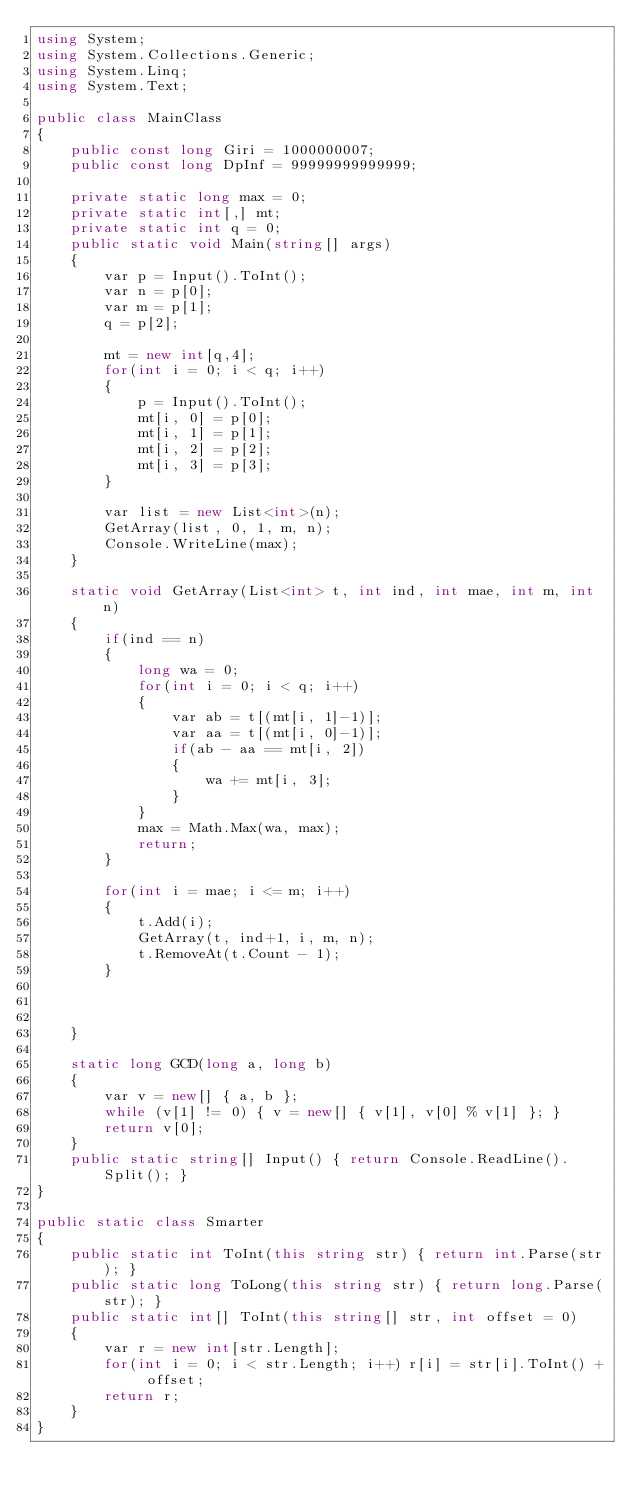<code> <loc_0><loc_0><loc_500><loc_500><_C#_>using System;
using System.Collections.Generic;
using System.Linq;
using System.Text;

public class MainClass
{
	public const long Giri = 1000000007;
	public const long DpInf = 99999999999999;
	
	private static long max = 0;
	private static int[,] mt;
	private static int q = 0;
	public static void Main(string[] args)
	{
		var p = Input().ToInt();
		var n = p[0];
		var m = p[1];
		q = p[2];
		
		mt = new int[q,4];
		for(int i = 0; i < q; i++)
		{
			p = Input().ToInt();
			mt[i, 0] = p[0];
			mt[i, 1] = p[1];
			mt[i, 2] = p[2];
			mt[i, 3] = p[3];
		}
		
		var list = new List<int>(n);
		GetArray(list, 0, 1, m, n);
		Console.WriteLine(max);
	}
	
	static void GetArray(List<int> t, int ind, int mae, int m, int n)
	{
		if(ind == n)
		{
			long wa = 0;
			for(int i = 0; i < q; i++)
			{
				var ab = t[(mt[i, 1]-1)];
				var aa = t[(mt[i, 0]-1)];
				if(ab - aa == mt[i, 2])
				{
					wa += mt[i, 3];
				}
			}
			max = Math.Max(wa, max);
			return;
		}
		
		for(int i = mae; i <= m; i++)
		{
			t.Add(i);
			GetArray(t, ind+1, i, m, n);
			t.RemoveAt(t.Count - 1);
		}
		
		
		
	}
	
	static long GCD(long a, long b)
	{
		var v = new[] { a, b };
		while (v[1] != 0) { v = new[] { v[1], v[0] % v[1] }; }
		return v[0];
	}
	public static string[] Input() { return Console.ReadLine().Split(); }
}

public static class Smarter
{
	public static int ToInt(this string str) { return int.Parse(str); }
	public static long ToLong(this string str) { return long.Parse(str); }
	public static int[] ToInt(this string[] str, int offset = 0)
	{
		var r = new int[str.Length];
		for(int i = 0; i < str.Length; i++) r[i] = str[i].ToInt() + offset;
		return r;
	}
}</code> 